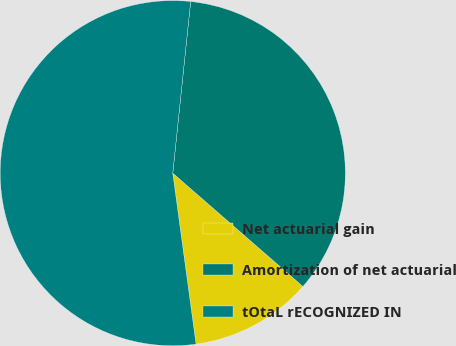Convert chart to OTSL. <chart><loc_0><loc_0><loc_500><loc_500><pie_chart><fcel>Net actuarial gain<fcel>Amortization of net actuarial<fcel>tOtaL rECOGNIZED IN<nl><fcel>11.44%<fcel>34.75%<fcel>53.81%<nl></chart> 